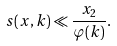Convert formula to latex. <formula><loc_0><loc_0><loc_500><loc_500>s ( x , k ) \ll \frac { x _ { 2 } } { \varphi ( k ) } .</formula> 